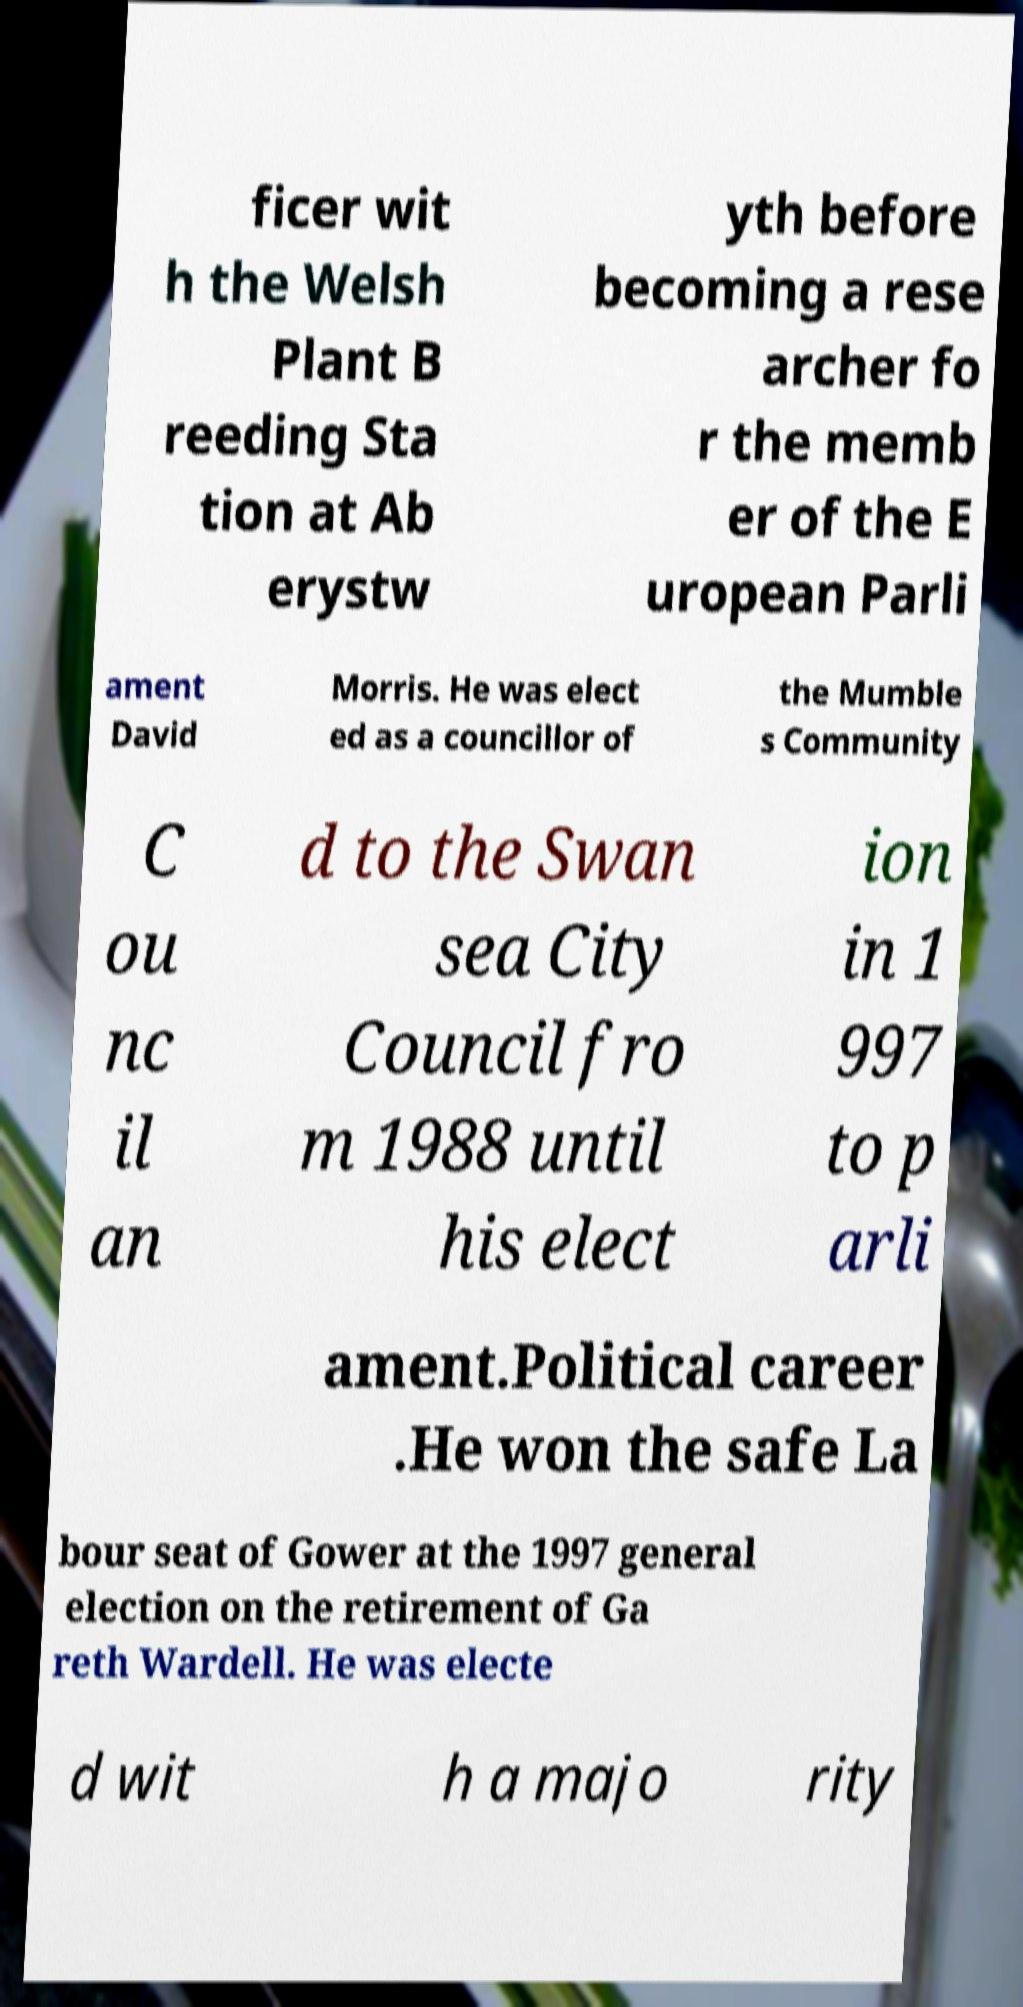Can you read and provide the text displayed in the image?This photo seems to have some interesting text. Can you extract and type it out for me? ficer wit h the Welsh Plant B reeding Sta tion at Ab erystw yth before becoming a rese archer fo r the memb er of the E uropean Parli ament David Morris. He was elect ed as a councillor of the Mumble s Community C ou nc il an d to the Swan sea City Council fro m 1988 until his elect ion in 1 997 to p arli ament.Political career .He won the safe La bour seat of Gower at the 1997 general election on the retirement of Ga reth Wardell. He was electe d wit h a majo rity 